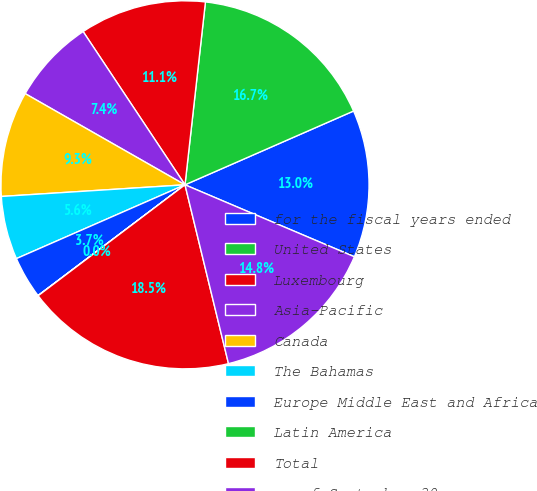Convert chart. <chart><loc_0><loc_0><loc_500><loc_500><pie_chart><fcel>for the fiscal years ended<fcel>United States<fcel>Luxembourg<fcel>Asia-Pacific<fcel>Canada<fcel>The Bahamas<fcel>Europe Middle East and Africa<fcel>Latin America<fcel>Total<fcel>as of September 30<nl><fcel>12.96%<fcel>16.66%<fcel>11.11%<fcel>7.41%<fcel>9.26%<fcel>5.56%<fcel>3.71%<fcel>0.02%<fcel>18.5%<fcel>14.81%<nl></chart> 